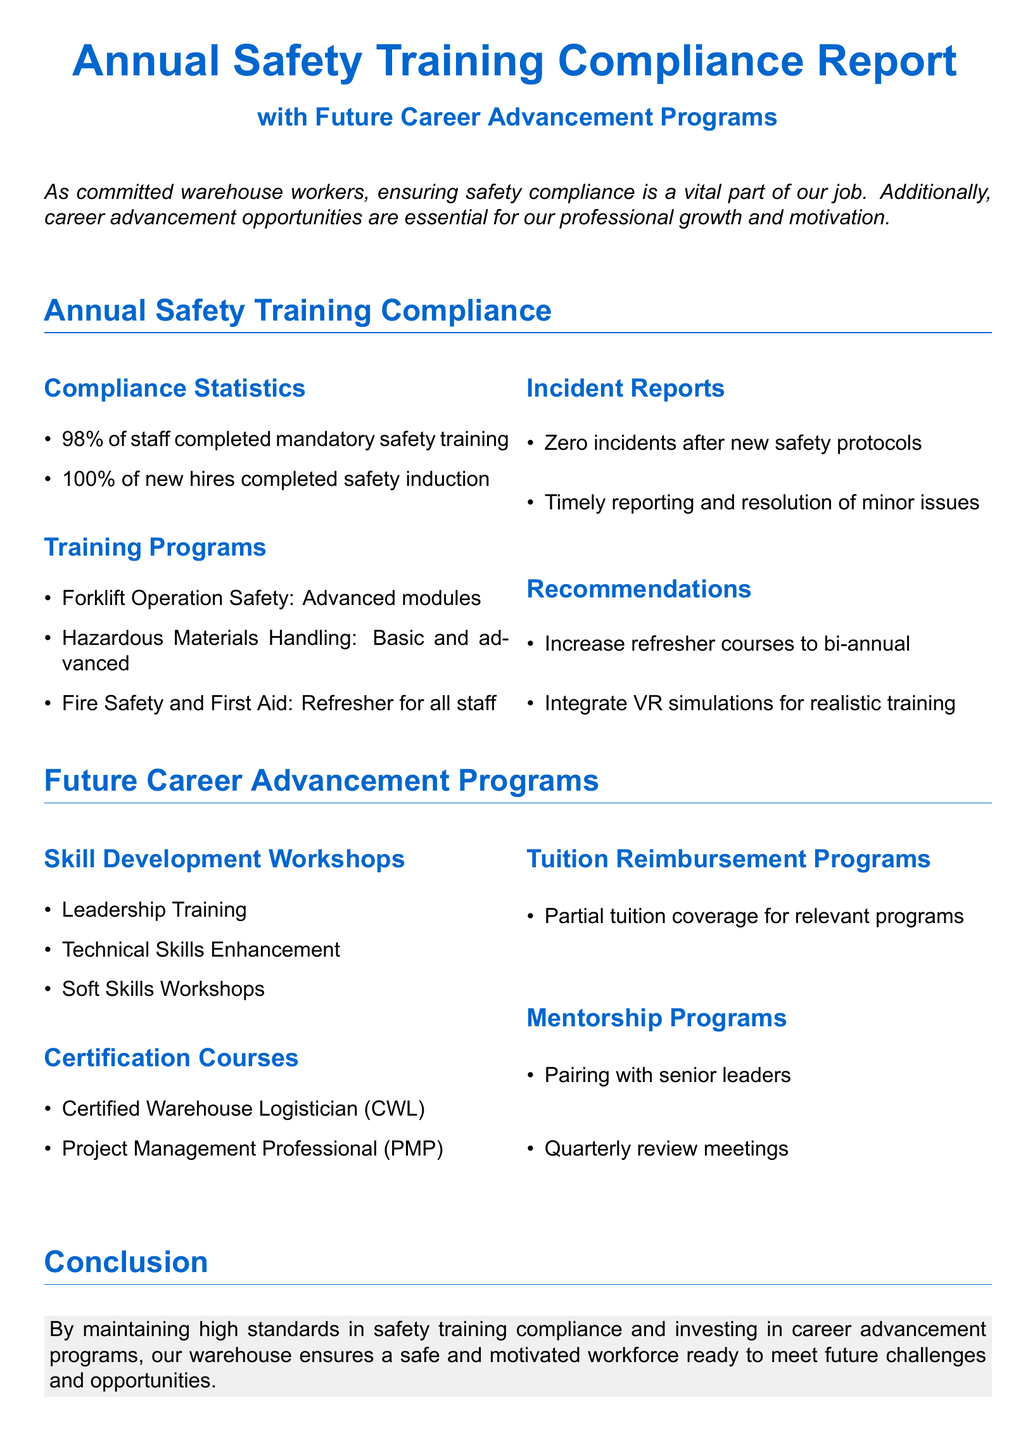What percentage of staff completed mandatory safety training? The document states that 98% of staff completed the training.
Answer: 98% What is the completion rate of new hires for safety induction? According to the document, 100% of new hires completed safety induction.
Answer: 100% What recommendation is made regarding refresher courses? The document suggests increasing refresher courses to a bi-annual frequency.
Answer: Bi-annual What course is offered under Skill Development Workshops? The document lists Leadership Training as one of the workshops.
Answer: Leadership Training What certification course is mentioned for project management? The document includes the Project Management Professional (PMP) course.
Answer: Project Management Professional How many incident reports occurred after new safety protocols? The document states that there were zero incidents.
Answer: Zero What type of programs does the Tuition Reimbursement cover? The document mentions partial tuition coverage for relevant programs.
Answer: Partial tuition coverage What training involves VR simulations? The document recommends integrating VR simulations for realistic training.
Answer: VR simulations What type of meetings occur in the Mentorship Programs? The document mentions quarterly review meetings.
Answer: Quarterly review meetings 